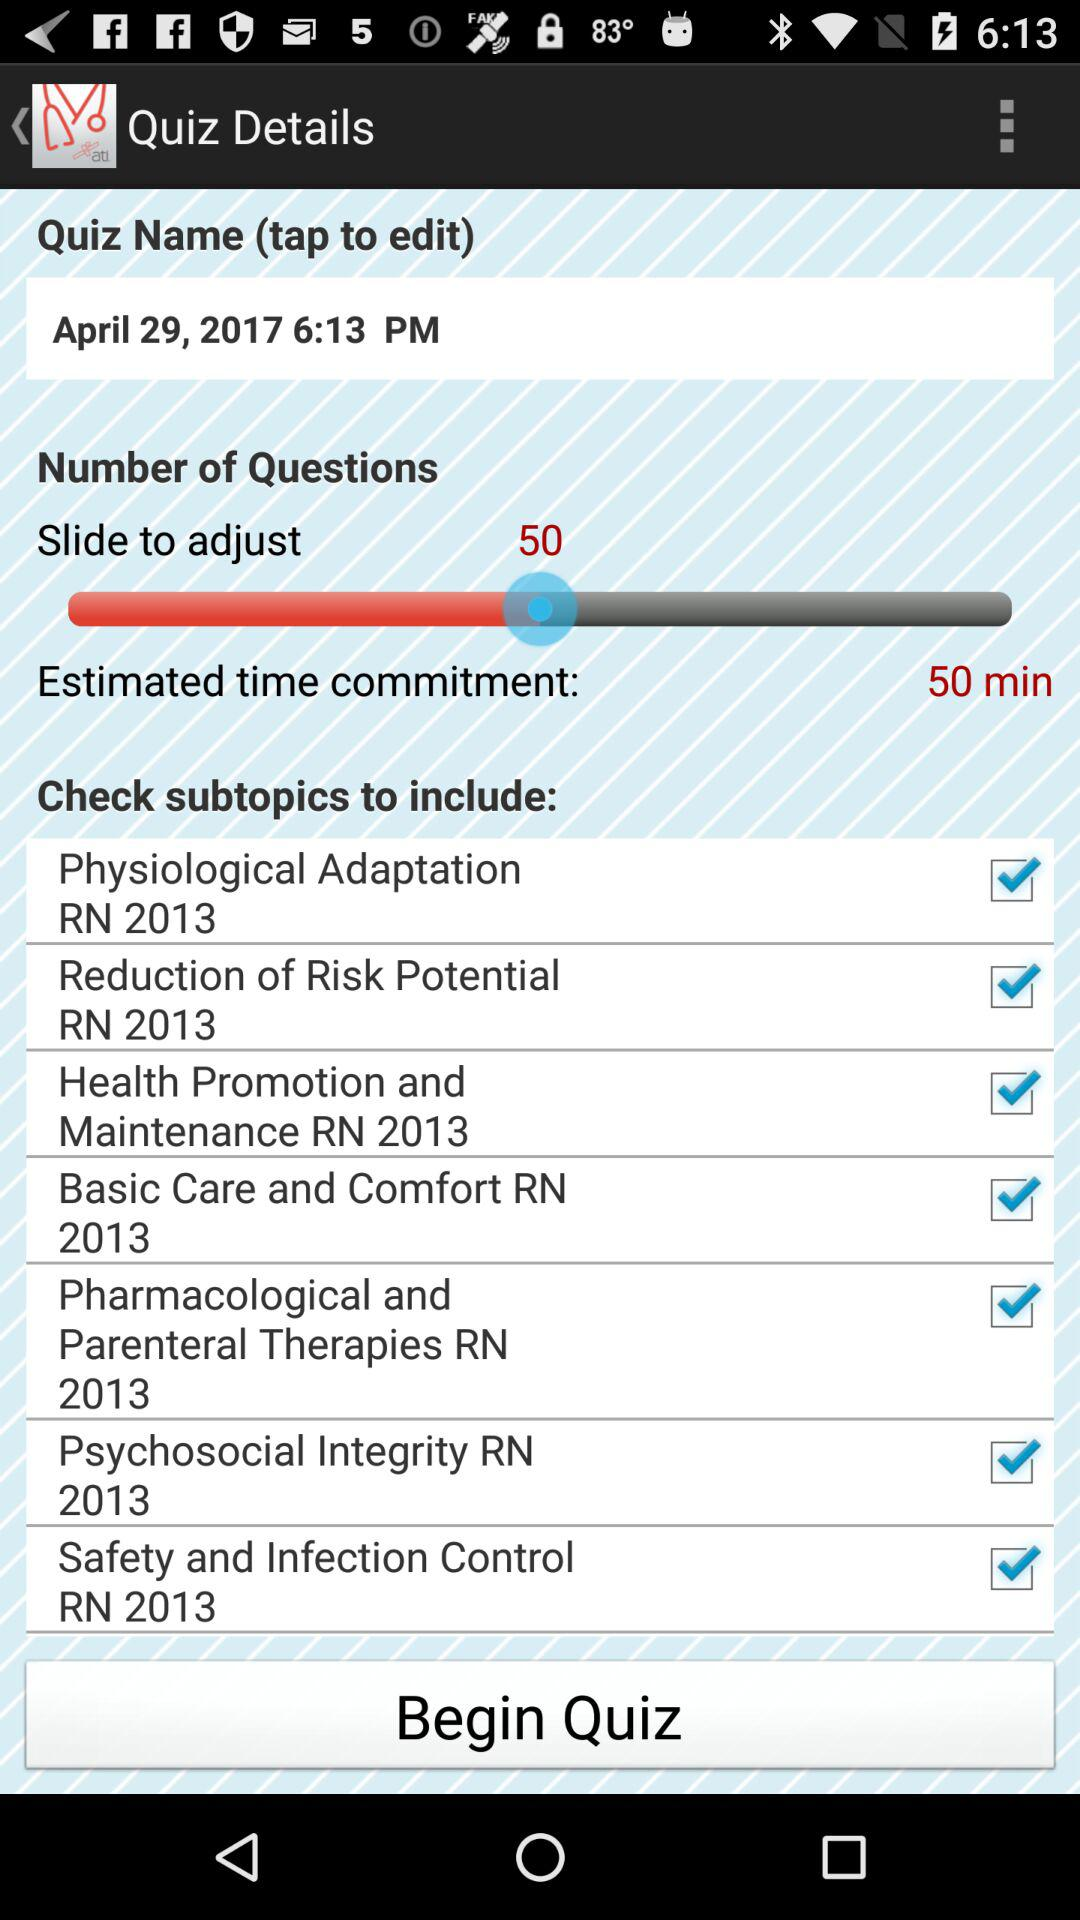What is the date? The date is April 29, 2017. 